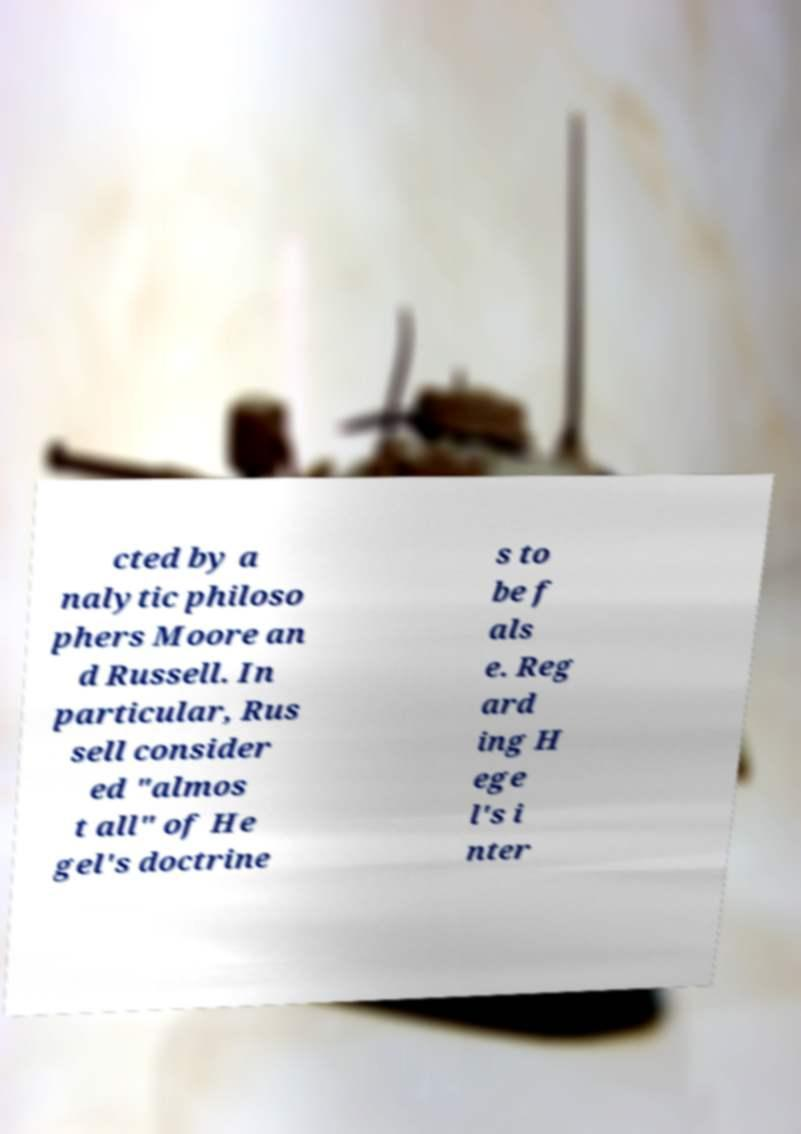What messages or text are displayed in this image? I need them in a readable, typed format. cted by a nalytic philoso phers Moore an d Russell. In particular, Rus sell consider ed "almos t all" of He gel's doctrine s to be f als e. Reg ard ing H ege l's i nter 